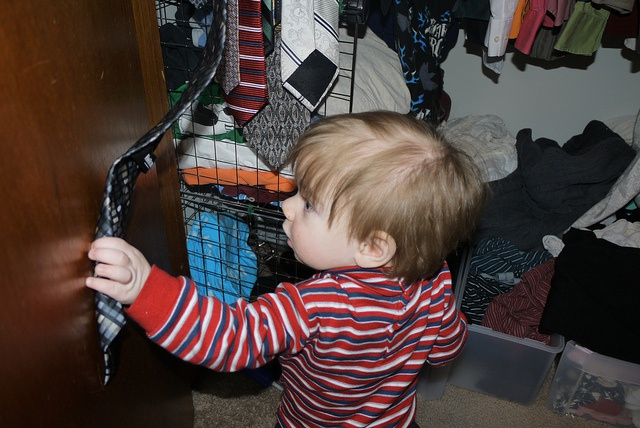Describe the objects in this image and their specific colors. I can see people in maroon, darkgray, brown, and black tones, tie in maroon, black, gray, and darkgray tones, tie in maroon, lightgray, black, and darkgray tones, tie in maroon, gray, and black tones, and tie in maroon, black, brown, and gray tones in this image. 